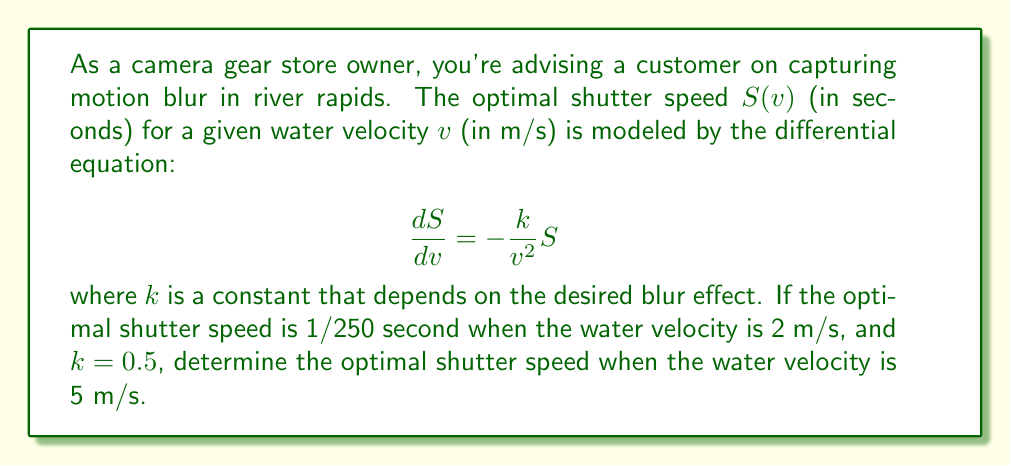What is the answer to this math problem? To solve this problem, we'll follow these steps:

1) First, we need to solve the given differential equation. It's a separable equation, so we can rewrite it as:

   $$\frac{dS}{S} = -\frac{k}{v^2}dv$$

2) Integrating both sides:

   $$\int \frac{dS}{S} = -k \int \frac{dv}{v^2}$$

   $$\ln|S| = \frac{k}{v} + C$$

3) Solving for S:

   $$S = Ce^{k/v}$$

   where C is a constant of integration.

4) Now we can use the given condition to find C. When $v = 2$ m/s, $S = 1/250$ s, and $k = 0.5$:

   $$\frac{1}{250} = Ce^{0.5/2} = Ce^{0.25}$$

   $$C = \frac{1}{250e^{0.25}}$$

5) Now we have the complete solution:

   $$S = \frac{1}{250e^{0.25}}e^{0.5/v}$$

6) To find the optimal shutter speed when $v = 5$ m/s, we simply substitute this value:

   $$S = \frac{1}{250e^{0.25}}e^{0.5/5} = \frac{1}{250e^{0.25}}e^{0.1}$$

7) Calculating this value:

   $$S \approx 0.00315 \text{ seconds}$$

This is approximately 1/317 of a second.
Answer: The optimal shutter speed when the water velocity is 5 m/s is approximately 1/317 second or 0.00315 seconds. 